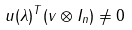Convert formula to latex. <formula><loc_0><loc_0><loc_500><loc_500>u ( \lambda ) ^ { T } ( v \otimes I _ { n } ) \neq 0</formula> 